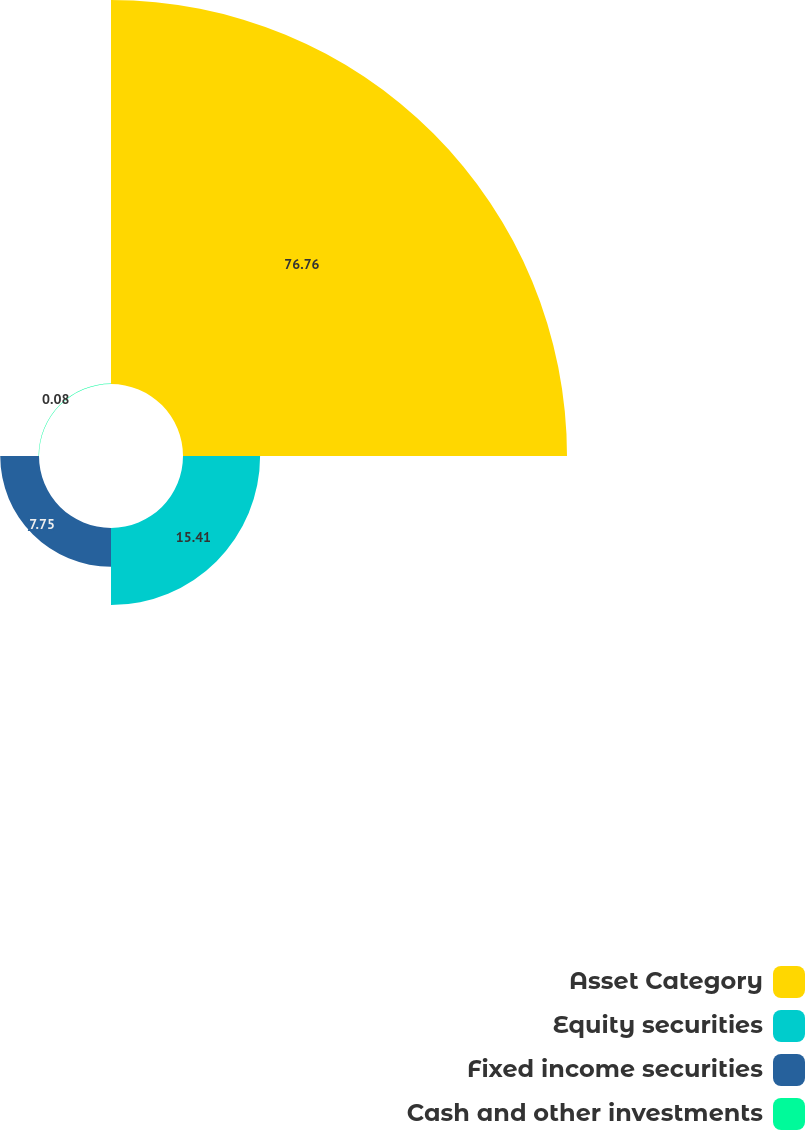Convert chart. <chart><loc_0><loc_0><loc_500><loc_500><pie_chart><fcel>Asset Category<fcel>Equity securities<fcel>Fixed income securities<fcel>Cash and other investments<nl><fcel>76.76%<fcel>15.41%<fcel>7.75%<fcel>0.08%<nl></chart> 